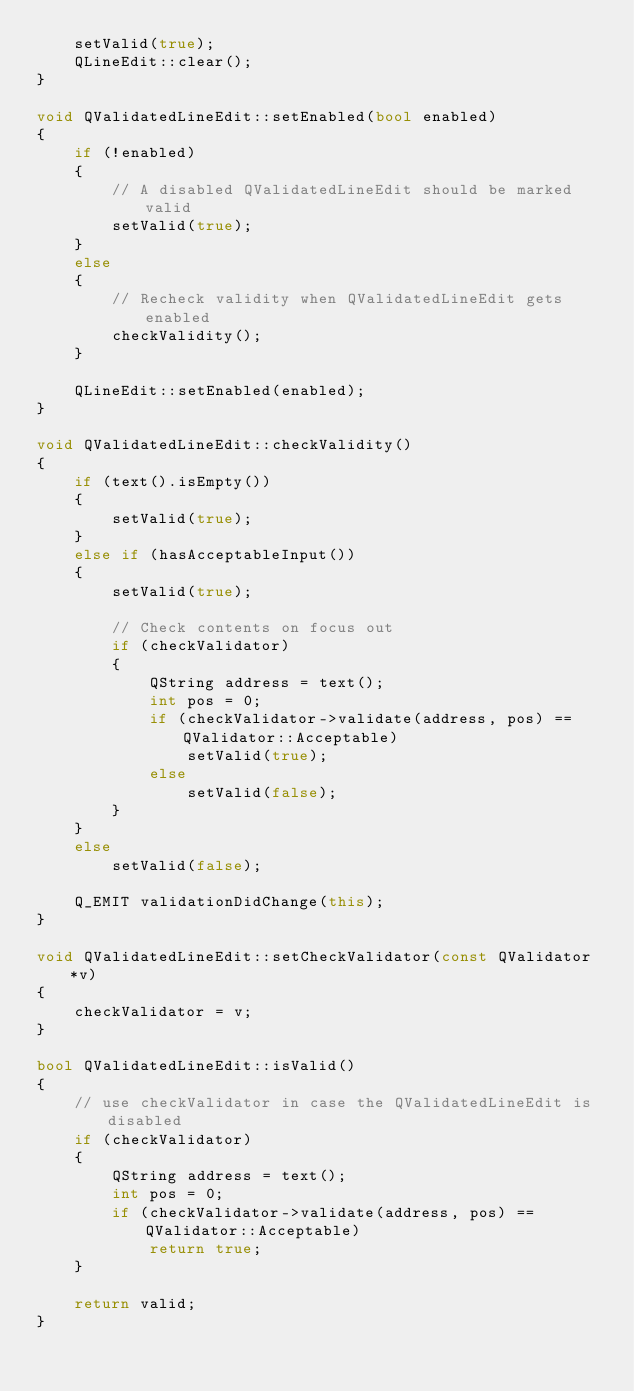Convert code to text. <code><loc_0><loc_0><loc_500><loc_500><_C++_>    setValid(true);
    QLineEdit::clear();
}

void QValidatedLineEdit::setEnabled(bool enabled)
{
    if (!enabled)
    {
        // A disabled QValidatedLineEdit should be marked valid
        setValid(true);
    }
    else
    {
        // Recheck validity when QValidatedLineEdit gets enabled
        checkValidity();
    }

    QLineEdit::setEnabled(enabled);
}

void QValidatedLineEdit::checkValidity()
{
    if (text().isEmpty())
    {
        setValid(true);
    }
    else if (hasAcceptableInput())
    {
        setValid(true);

        // Check contents on focus out
        if (checkValidator)
        {
            QString address = text();
            int pos = 0;
            if (checkValidator->validate(address, pos) == QValidator::Acceptable)
                setValid(true);
            else
                setValid(false);
        }
    }
    else
        setValid(false);

    Q_EMIT validationDidChange(this);
}

void QValidatedLineEdit::setCheckValidator(const QValidator *v)
{
    checkValidator = v;
}

bool QValidatedLineEdit::isValid()
{
    // use checkValidator in case the QValidatedLineEdit is disabled
    if (checkValidator)
    {
        QString address = text();
        int pos = 0;
        if (checkValidator->validate(address, pos) == QValidator::Acceptable)
            return true;
    }

    return valid;
}
</code> 